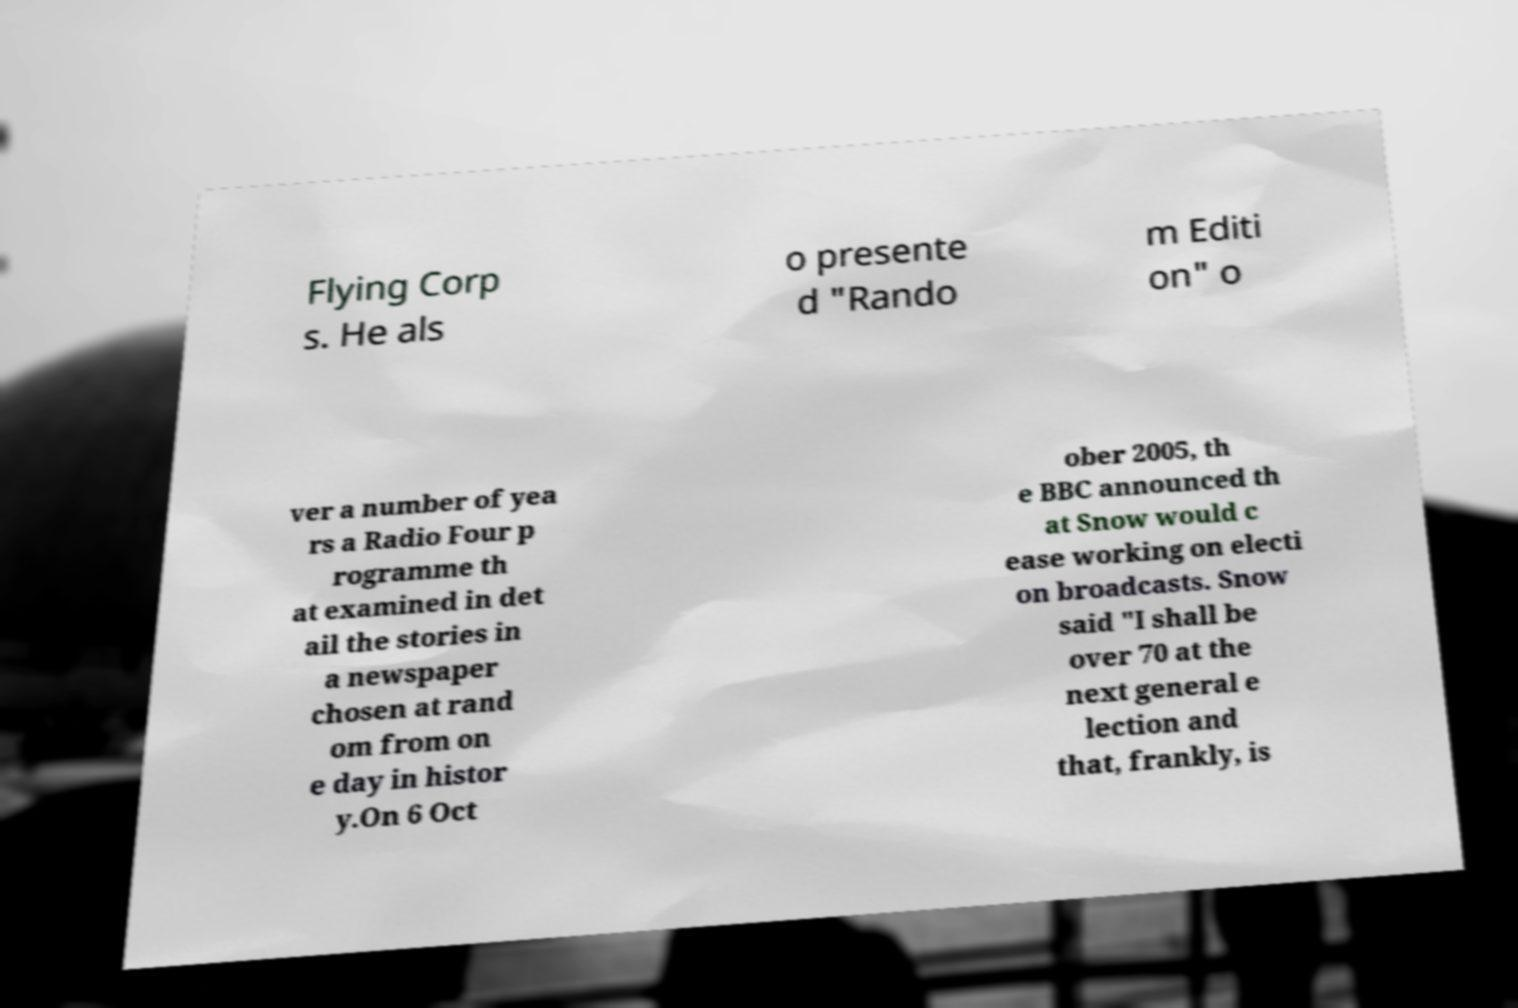Please read and relay the text visible in this image. What does it say? Flying Corp s. He als o presente d "Rando m Editi on" o ver a number of yea rs a Radio Four p rogramme th at examined in det ail the stories in a newspaper chosen at rand om from on e day in histor y.On 6 Oct ober 2005, th e BBC announced th at Snow would c ease working on electi on broadcasts. Snow said "I shall be over 70 at the next general e lection and that, frankly, is 